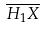<formula> <loc_0><loc_0><loc_500><loc_500>\overline { H _ { 1 } X }</formula> 